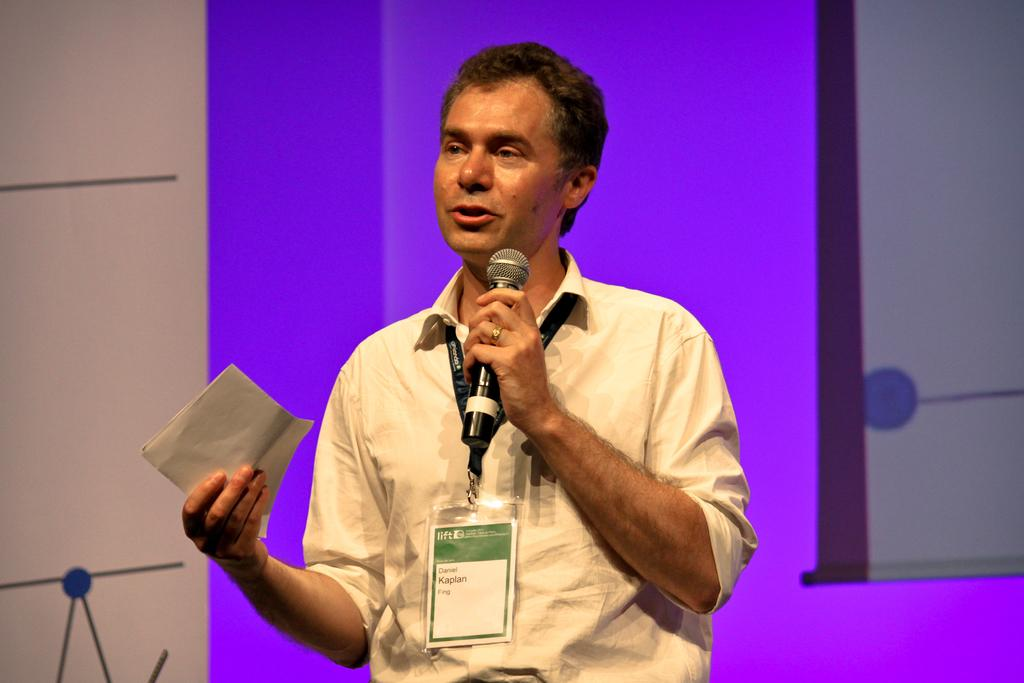Who is in the image? There is a man in the image. What is the man wearing? The man is wearing a cream-colored shirt. Does the man have any identification? Yes, the man has an ID card. What is the man doing in the image? The man is talking on a microphone and holding a paper. What can be seen in the background of the image? There is a wall in the background of the image, and it has a purple color on it. How many spiders are crawling on the man's shirt in the image? There are no spiders visible on the man's shirt in the image. What is the title of the speech the man is giving in the image? The image does not provide any information about the content of the man's speech, so we cannot determine the title. 